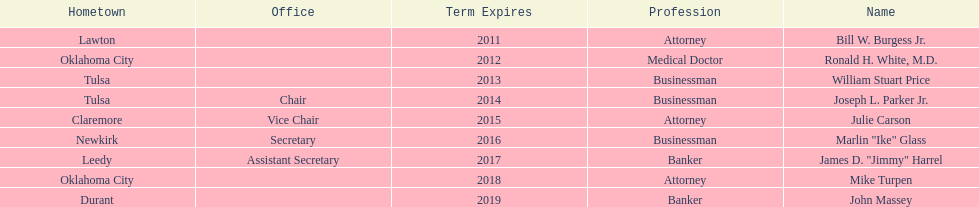Which state regent's term will last the longest? John Massey. 